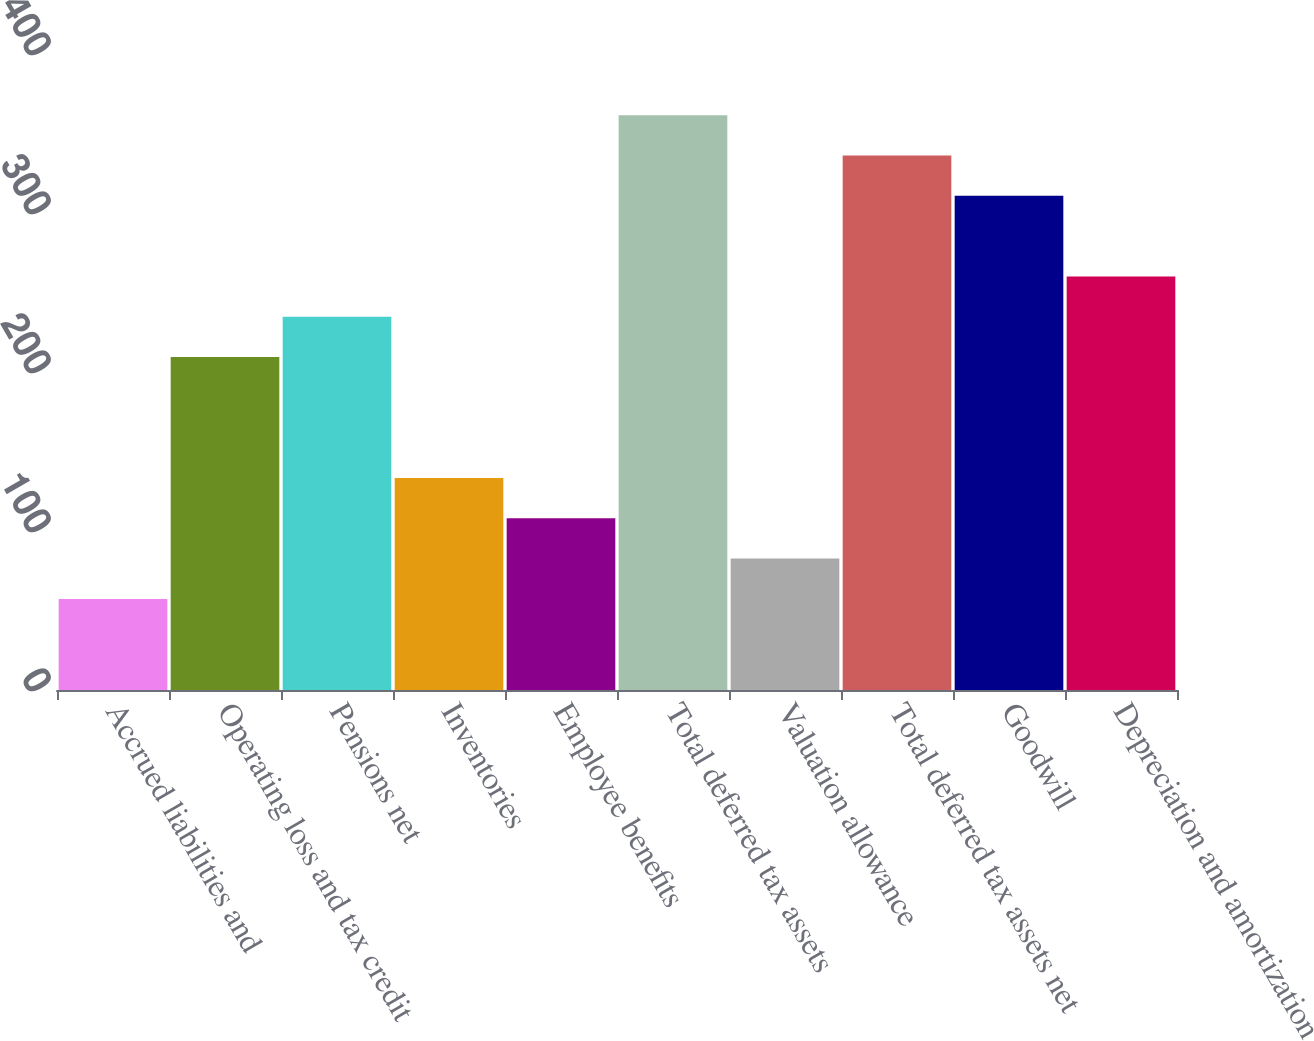<chart> <loc_0><loc_0><loc_500><loc_500><bar_chart><fcel>Accrued liabilities and<fcel>Operating loss and tax credit<fcel>Pensions net<fcel>Inventories<fcel>Employee benefits<fcel>Total deferred tax assets<fcel>Valuation allowance<fcel>Total deferred tax assets net<fcel>Goodwill<fcel>Depreciation and amortization<nl><fcel>57.3<fcel>209.4<fcel>234.75<fcel>133.35<fcel>108<fcel>361.5<fcel>82.65<fcel>336.15<fcel>310.8<fcel>260.1<nl></chart> 